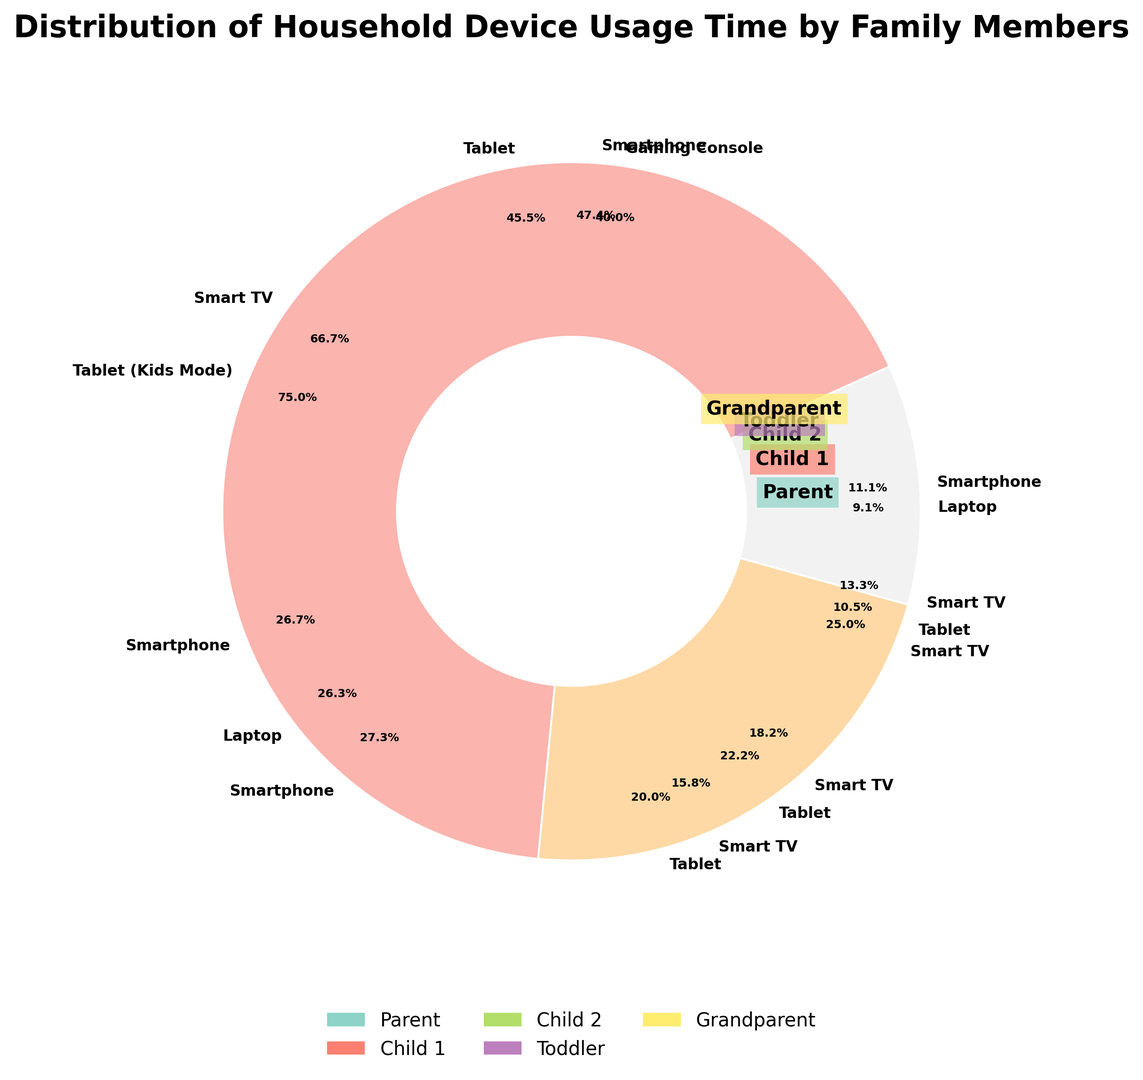What is the total usage time for the Parent? Total usage time for the Parent can be calculated by summing the usage times for Smartphone, Laptop, Smart TV, and Tablet: 4.5 + 2.5 + 1.5 + 1.0.
Answer: 9.5 hours Which family member uses the Smart TV the most? By comparing the usage times for each family member with Smart TV, it's clear that the Grandparent uses it the most with 3.0 hours.
Answer: Grandparent How does Child 1's total usage time on Tablet compare to Child 2’s? Comparing Child 1's and Child 2's Tablet usage times, Child 1 uses it for 1.5 hours, whereas Child 2 uses it for 2.5 hours. Child 2 uses it more.
Answer: Child 2 uses it more Who has the least total device usage time and what is that time? By summing the device usage times for each family member and comparing them, Toddler has the least total device usage time at 2.0 hours (1.5 on Tablet (Kids Mode) and 0.5 on Smart TV).
Answer: Toddler, 2.0 hours What is the proportion of Smartphone usage for Child 2 compared to total Smartphone usage across the family? Summing total Smartphone usage: Parent – 4.5, Child 1 – 2.0, Child 2 – 1.5, Grandparent – 0.5 gives 8.5 hours. Child 2 uses 1.5 hours out of this total. So the proportion is 1.5/8.5.
Answer: ~17.6% Which device type has the highest total usage across all family members? Adding up usage times for each device across family members: Smartphones - 8.5, Tablets - 6.5, Smart TVs - 7, Laptops - 3, Gaming Console - 3. The Smartphone has the highest total usage.
Answer: Smartphone How does the usage time of Smart TV by the Parent compare to that by the Grandparent? The Parent uses the Smart TV for 1.5 hours, whereas the Grandparent uses it for 3.0 hours. The Grandparent uses it twice as much.
Answer: Grandparent uses it more What is the most frequently used device type by the Toddler? Comparing device usage times for the Toddler: Tablet (Kids Mode) is used for 1.5 hours, whereas Smart TV is used for 0.5 hours. Tablet (Kids Mode) is used most frequently.
Answer: Tablet (Kids Mode) What is the average device usage time for Child 1 across all devices? Summing usage times for Child 1 (3.0 + 2.0 + 1.5 + 1.0 = 7.5) and dividing by 4 (the number of devices): 7.5/4.
Answer: 1.88 hours What is the combined Smart TV usage time for all children (Child 1, Child 2, Toddler)? Adding Smart TV usage times: Child 1 – 1.0, Child 2 – 1.0, Toddler – 0.5 gives 1.0 + 1.0 + 0.5.
Answer: 2.5 hours 